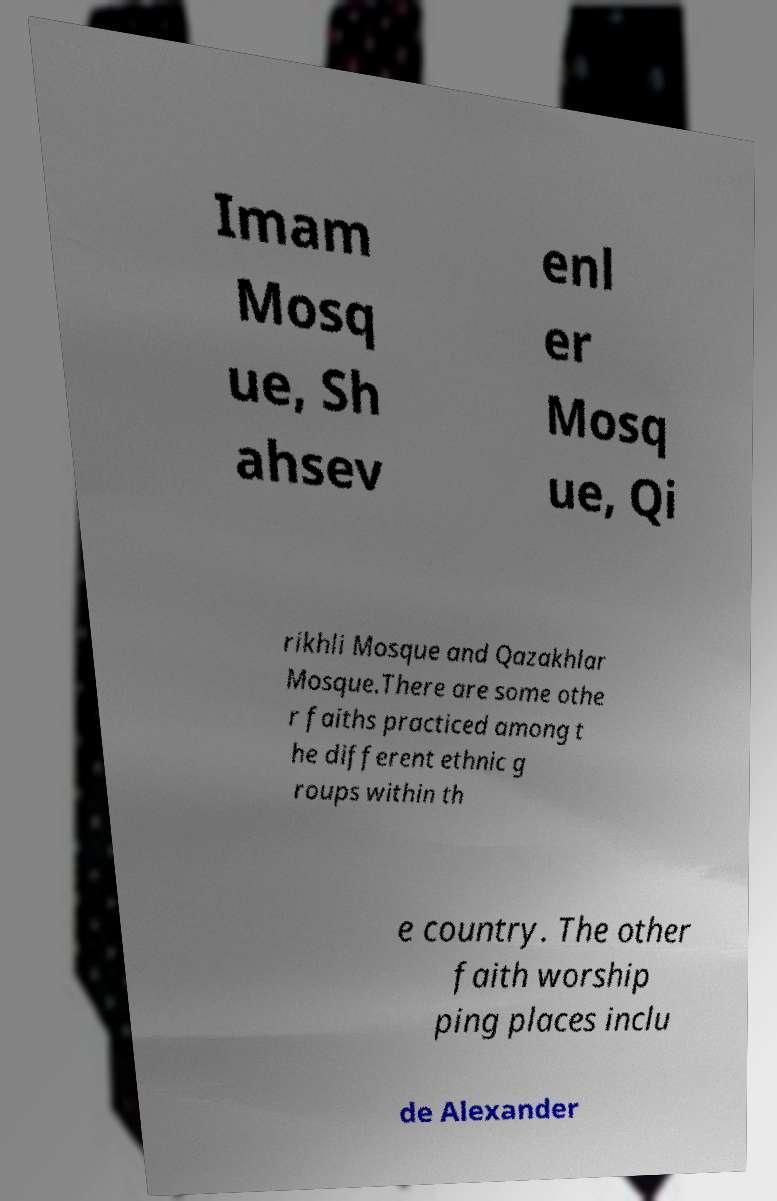Please read and relay the text visible in this image. What does it say? Imam Mosq ue, Sh ahsev enl er Mosq ue, Qi rikhli Mosque and Qazakhlar Mosque.There are some othe r faiths practiced among t he different ethnic g roups within th e country. The other faith worship ping places inclu de Alexander 